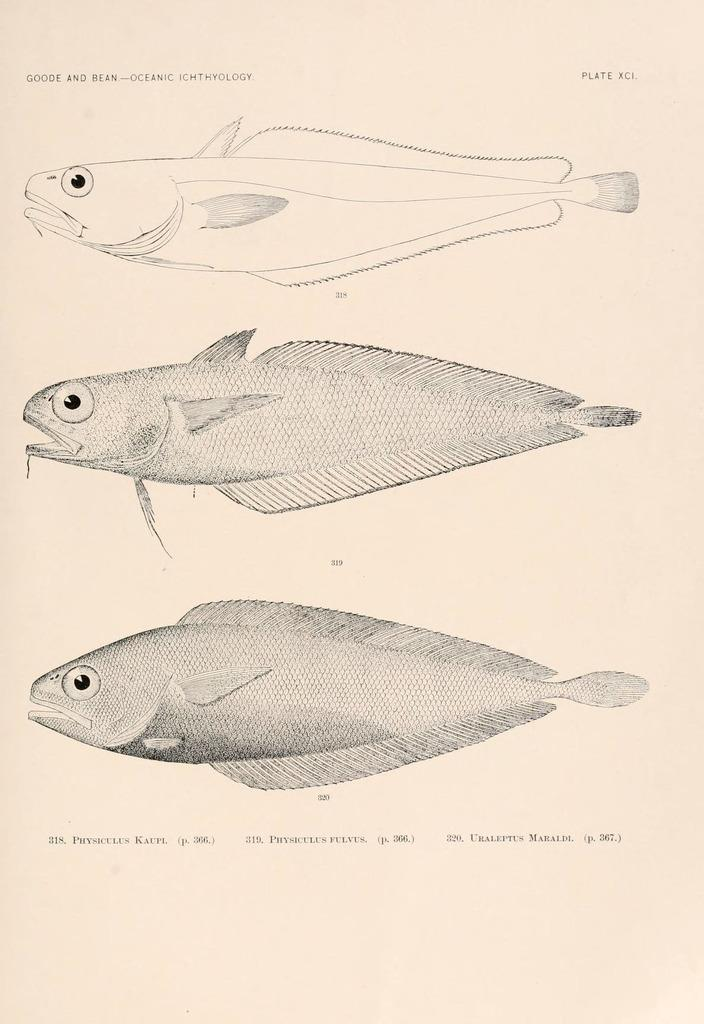What is depicted in the image? There is a drawing of a fish in the image. What else can be found in the image besides the drawing of the fish? There is text in the image. What type of apparatus is being used to catch the fish in the image? There is no apparatus present in the image, as it only contains a drawing of a fish and text. 